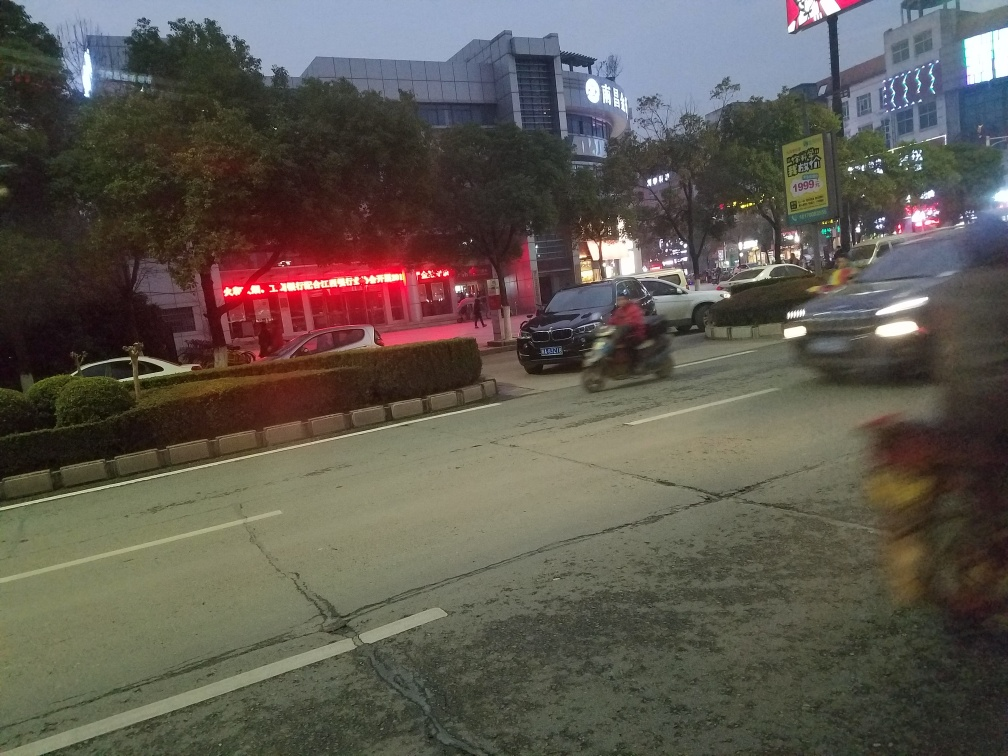Have the trees lost some texture details in the image? Yes, the trees in the image appear to have lost some texture details. This can happen due to the camera's focus being on another element of the scene, or the image might have been taken with a low-resolution camera or in low-light conditions, all of which can reduce the sharpness and detail of distant objects like trees. 